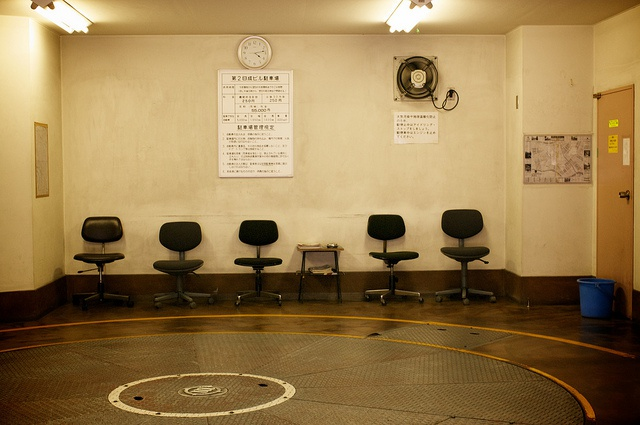Describe the objects in this image and their specific colors. I can see chair in tan, black, and olive tones, chair in tan, black, maroon, and olive tones, chair in tan, black, and olive tones, chair in tan, black, and olive tones, and chair in tan, black, and olive tones in this image. 